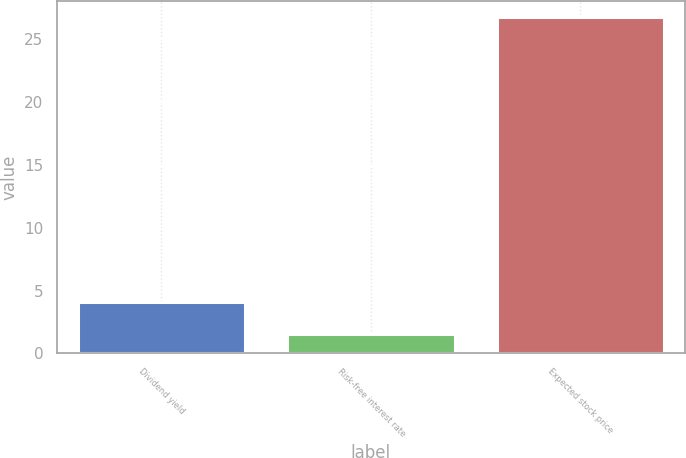<chart> <loc_0><loc_0><loc_500><loc_500><bar_chart><fcel>Dividend yield<fcel>Risk-free interest rate<fcel>Expected stock price<nl><fcel>4.09<fcel>1.57<fcel>26.76<nl></chart> 